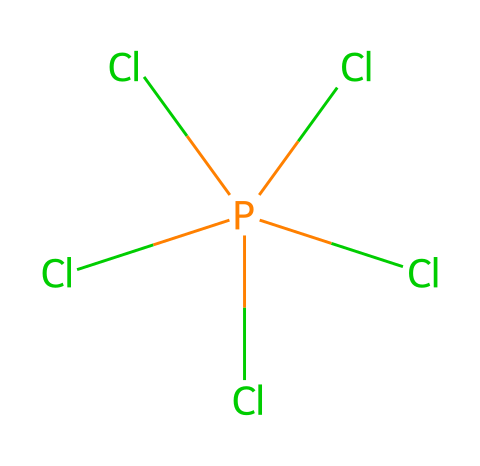How many chlorine atoms are present in phosphorus pentachloride? The chemical structure shows five chlorine (Cl) atoms connected to the phosphorus (P) atom. Each Cl is depicted in the SMILES representation, confirming their total count.
Answer: five What is the central atom in the phosphorus pentachloride molecule? The SMILES notation indicates that phosphorus (P) is the central atom, as it is the one single atom that connects to multiple chlorine atoms.
Answer: phosphorus What type of hybridization does phosphorus exhibit in this compound? Phosphorus is bonded to five chlorine atoms, which requires it to use all available orbitals for bonding instead of just three. This indicates sp³d hybridization is taking place.
Answer: sp³d What is the molecular geometry of phosphorus pentachloride? Given the presence of five bonding pairs around phosphorus and no lone pairs, the molecular geometry adopts a trigonal bipyramidal shape to minimize electron pair repulsion.
Answer: trigonal bipyramidal How many bond pairs are present around the central phosphorus atom in this compound? There are five chlorine atoms directly bonded to the central phosphorus atom, indicating that there are five bond pairs present.
Answer: five What category of compounds does phosphorus pentachloride belong to? Due to the presence of a central atom bonded to more than four substituents, phosphorus pentachloride is categorized as a hypervalent compound, which is characterized by having expanded octets.
Answer: hypervalent 